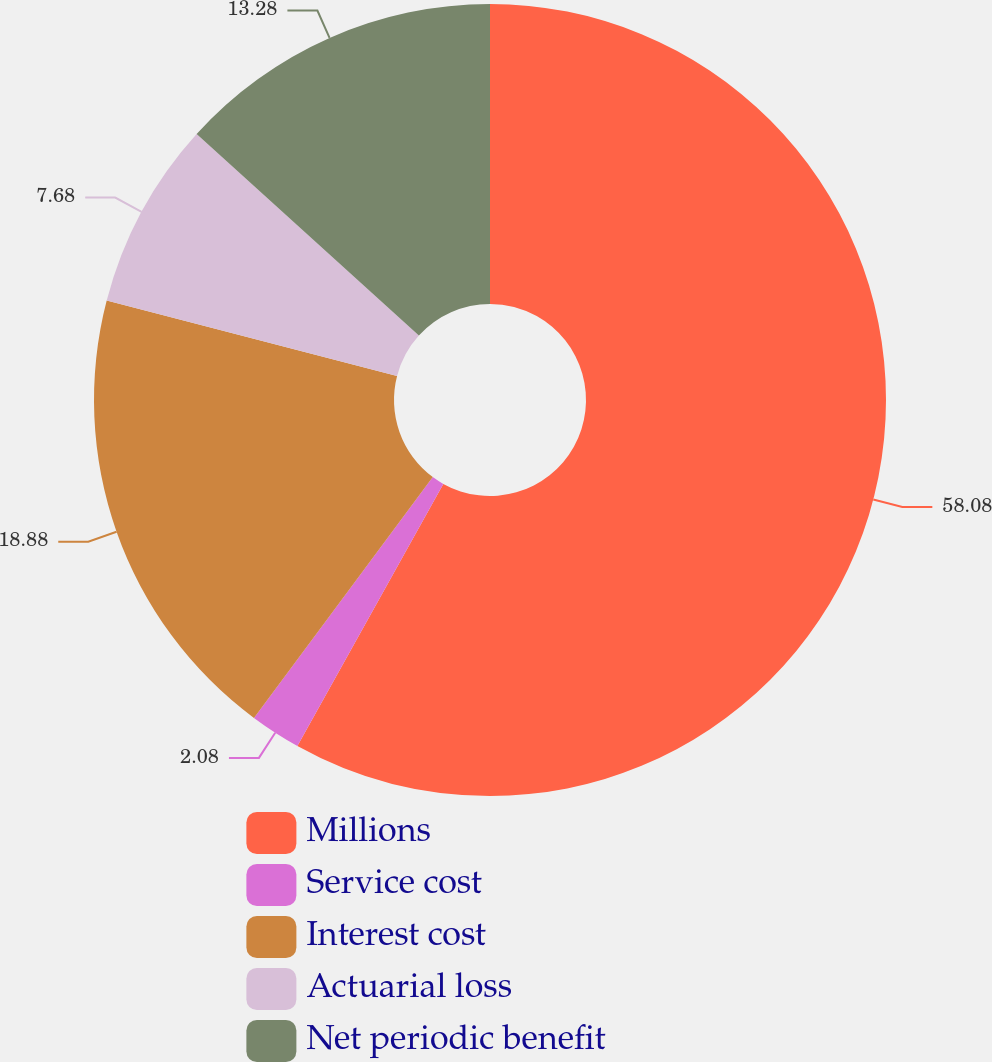<chart> <loc_0><loc_0><loc_500><loc_500><pie_chart><fcel>Millions<fcel>Service cost<fcel>Interest cost<fcel>Actuarial loss<fcel>Net periodic benefit<nl><fcel>58.09%<fcel>2.08%<fcel>18.88%<fcel>7.68%<fcel>13.28%<nl></chart> 